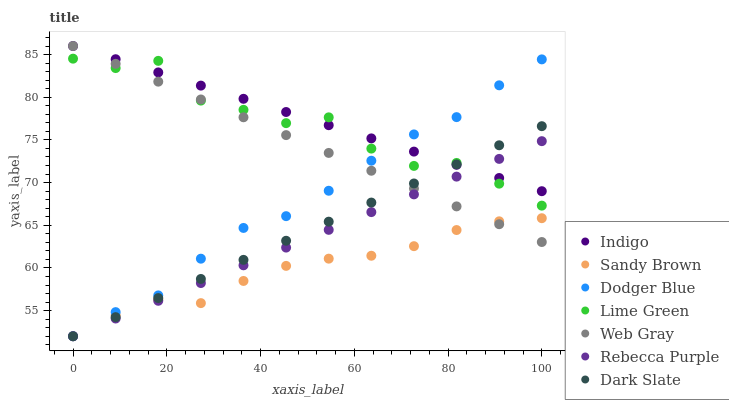Does Sandy Brown have the minimum area under the curve?
Answer yes or no. Yes. Does Indigo have the maximum area under the curve?
Answer yes or no. Yes. Does Indigo have the minimum area under the curve?
Answer yes or no. No. Does Sandy Brown have the maximum area under the curve?
Answer yes or no. No. Is Rebecca Purple the smoothest?
Answer yes or no. Yes. Is Lime Green the roughest?
Answer yes or no. Yes. Is Indigo the smoothest?
Answer yes or no. No. Is Indigo the roughest?
Answer yes or no. No. Does Sandy Brown have the lowest value?
Answer yes or no. Yes. Does Indigo have the lowest value?
Answer yes or no. No. Does Indigo have the highest value?
Answer yes or no. Yes. Does Sandy Brown have the highest value?
Answer yes or no. No. Is Sandy Brown less than Lime Green?
Answer yes or no. Yes. Is Indigo greater than Sandy Brown?
Answer yes or no. Yes. Does Indigo intersect Web Gray?
Answer yes or no. Yes. Is Indigo less than Web Gray?
Answer yes or no. No. Is Indigo greater than Web Gray?
Answer yes or no. No. Does Sandy Brown intersect Lime Green?
Answer yes or no. No. 